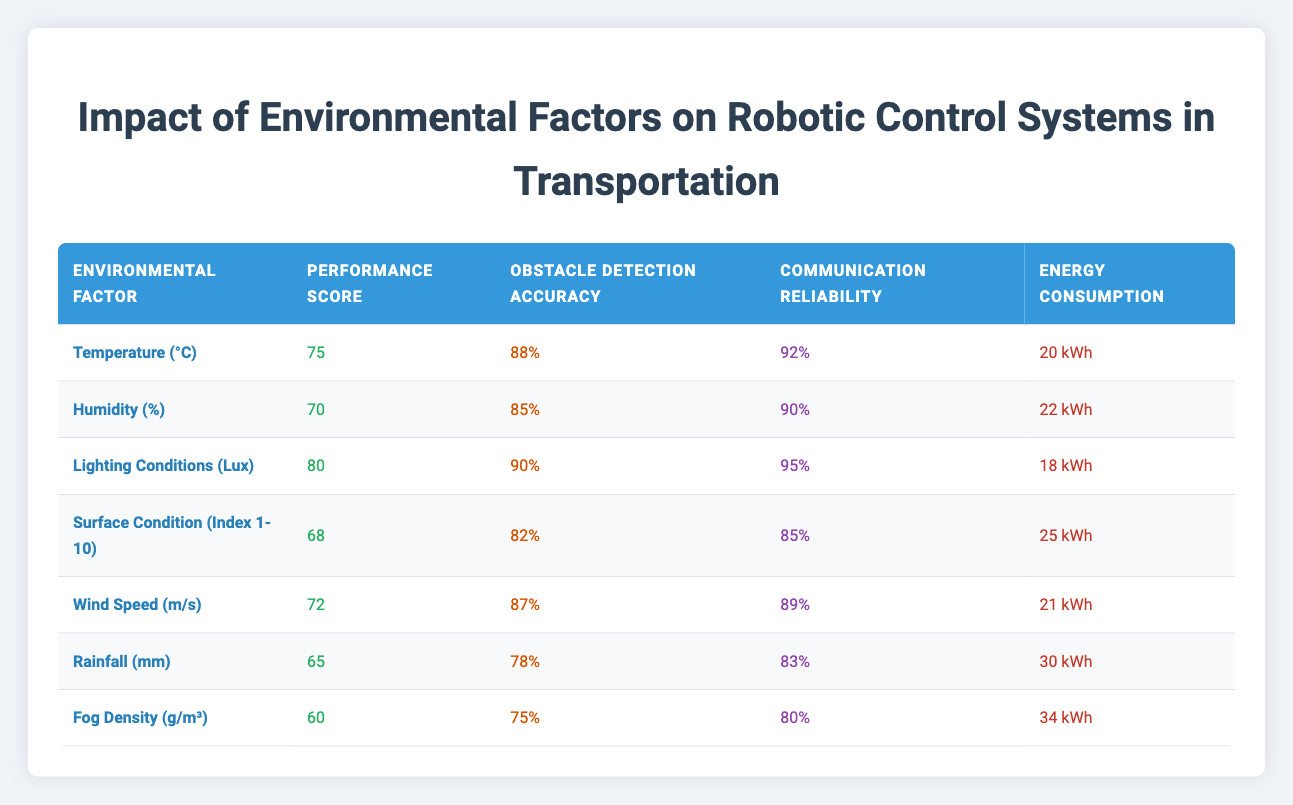What is the obstacle detection accuracy for lighting conditions (Lux)? The table shows the value for obstacle detection accuracy under the row for "Lighting Conditions (Lux)" which is stated as 90%.
Answer: 90% What is the energy consumption when the temperature is at 25 degrees Celsius? The table does not contain any data corresponding to a temperature of 25 degrees Celsius, as it only includes the value for "Temperature (°C)" which is 20 kWh.
Answer: No data Which environmental factor has the highest robotic system performance score? The "Performance Score" column indicates that "Lighting Conditions (Lux)" has the highest score of 80.
Answer: Lighting Conditions (Lux) What is the average communication reliability of all environmental factors? To find the average, sum all the values in the "Communication Reliability" column: 92 + 90 + 95 + 85 + 89 + 83 + 80 = 514. The total number of entries is 7, so the average is 514 / 7 ≈ 73.43%.
Answer: 73.43% Is the obstacle detection accuracy lower for rain than for fog density? The obstacle detection accuracy for "Rainfall (mm)" is 78% and for "Fog Density (g/m³)" it is 75%. Since 78% > 75%, the statement is true.
Answer: Yes What is the difference in energy consumption between fog density and lighting conditions? The energy consumption for "Fog Density (g/m³)" is 34 kWh, and for "Lighting Conditions (Lux)" it is 18 kWh. The difference is calculated as 34 - 18 = 16 kWh.
Answer: 16 kWh Which environmental factor has the lowest robotic system performance score? Upon examining the table, "Fog Density (g/m³)" with a robotic system performance score of 60 is the lowest.
Answer: Fog Density (g/m³) What is the combined obstacle detection accuracy for humidity and rainfall? The obstacle detection accuracy for "Humidity (%)" is 85% and "Rainfall (mm)" is 78%. When combined, it is 85 + 78 = 163%.
Answer: 163% 